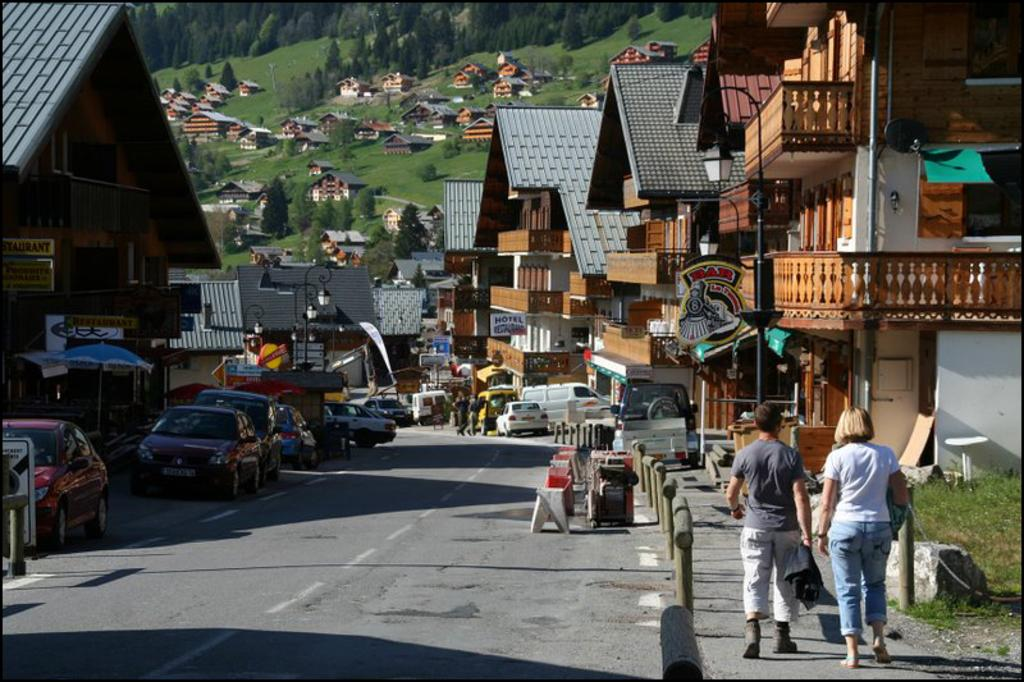What can be seen on the road in the image? There are vehicles on the road in the image. What are the people near the road doing? People are walking near the road in the image. What type of structures are located in the vicinity? There are houses in the vicinity. What type of vegetation is present in the area? Trees are present in the area. What type of shock can be seen affecting the vehicles in the image? There is no shock affecting the vehicles in the image; they appear to be moving normally on the road. What kind of trouble are the people near the road experiencing? There is no indication of trouble for the people near the road in the image; they are simply walking. 